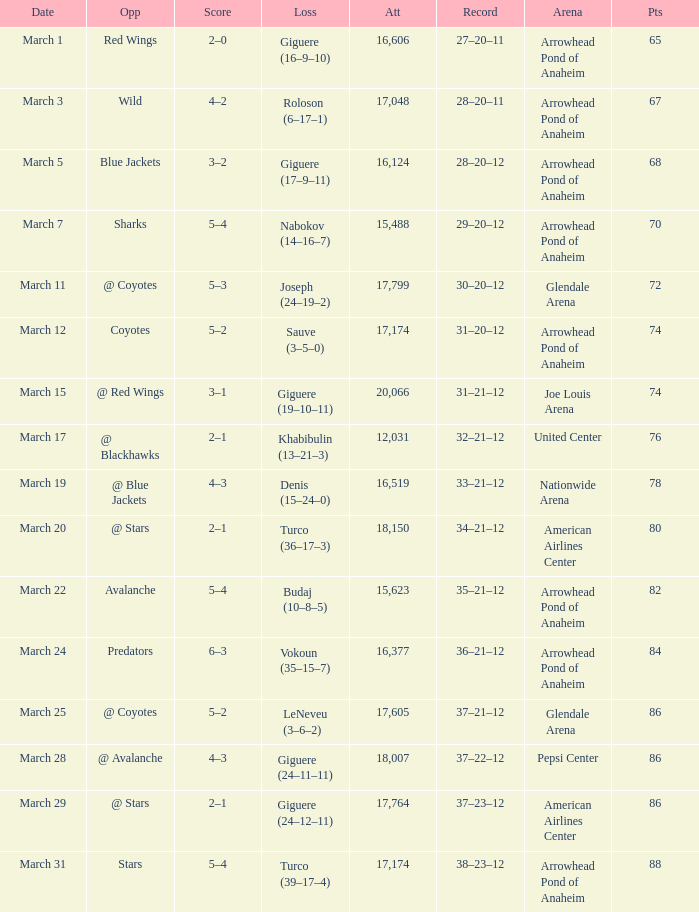What is the presence at the match with a record of 37-21-12 and under 86 points? None. 